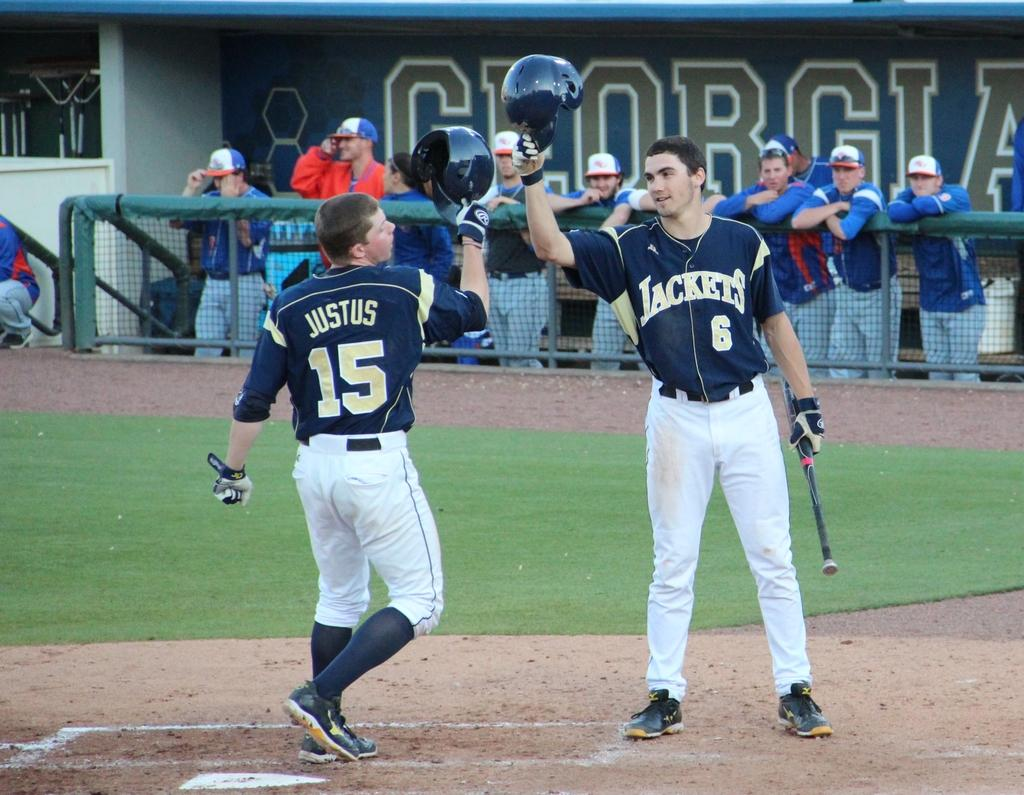<image>
Provide a brief description of the given image. baseball players from the Jackets team on the field 